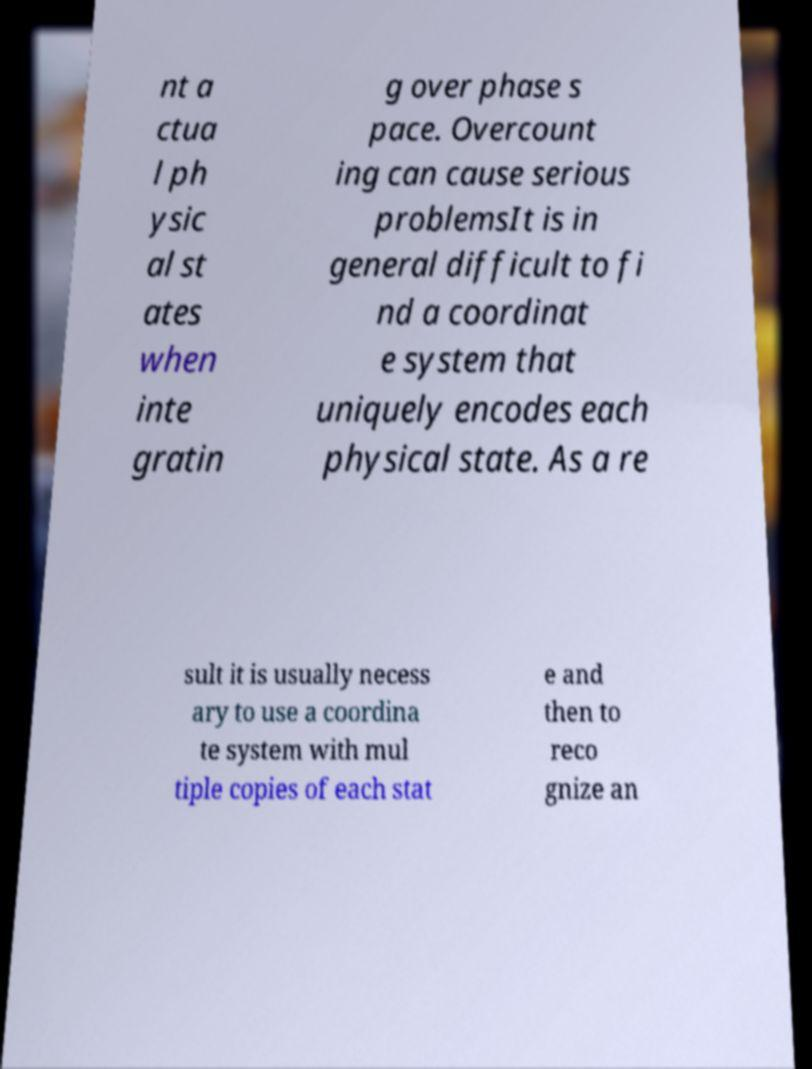Please read and relay the text visible in this image. What does it say? nt a ctua l ph ysic al st ates when inte gratin g over phase s pace. Overcount ing can cause serious problemsIt is in general difficult to fi nd a coordinat e system that uniquely encodes each physical state. As a re sult it is usually necess ary to use a coordina te system with mul tiple copies of each stat e and then to reco gnize an 